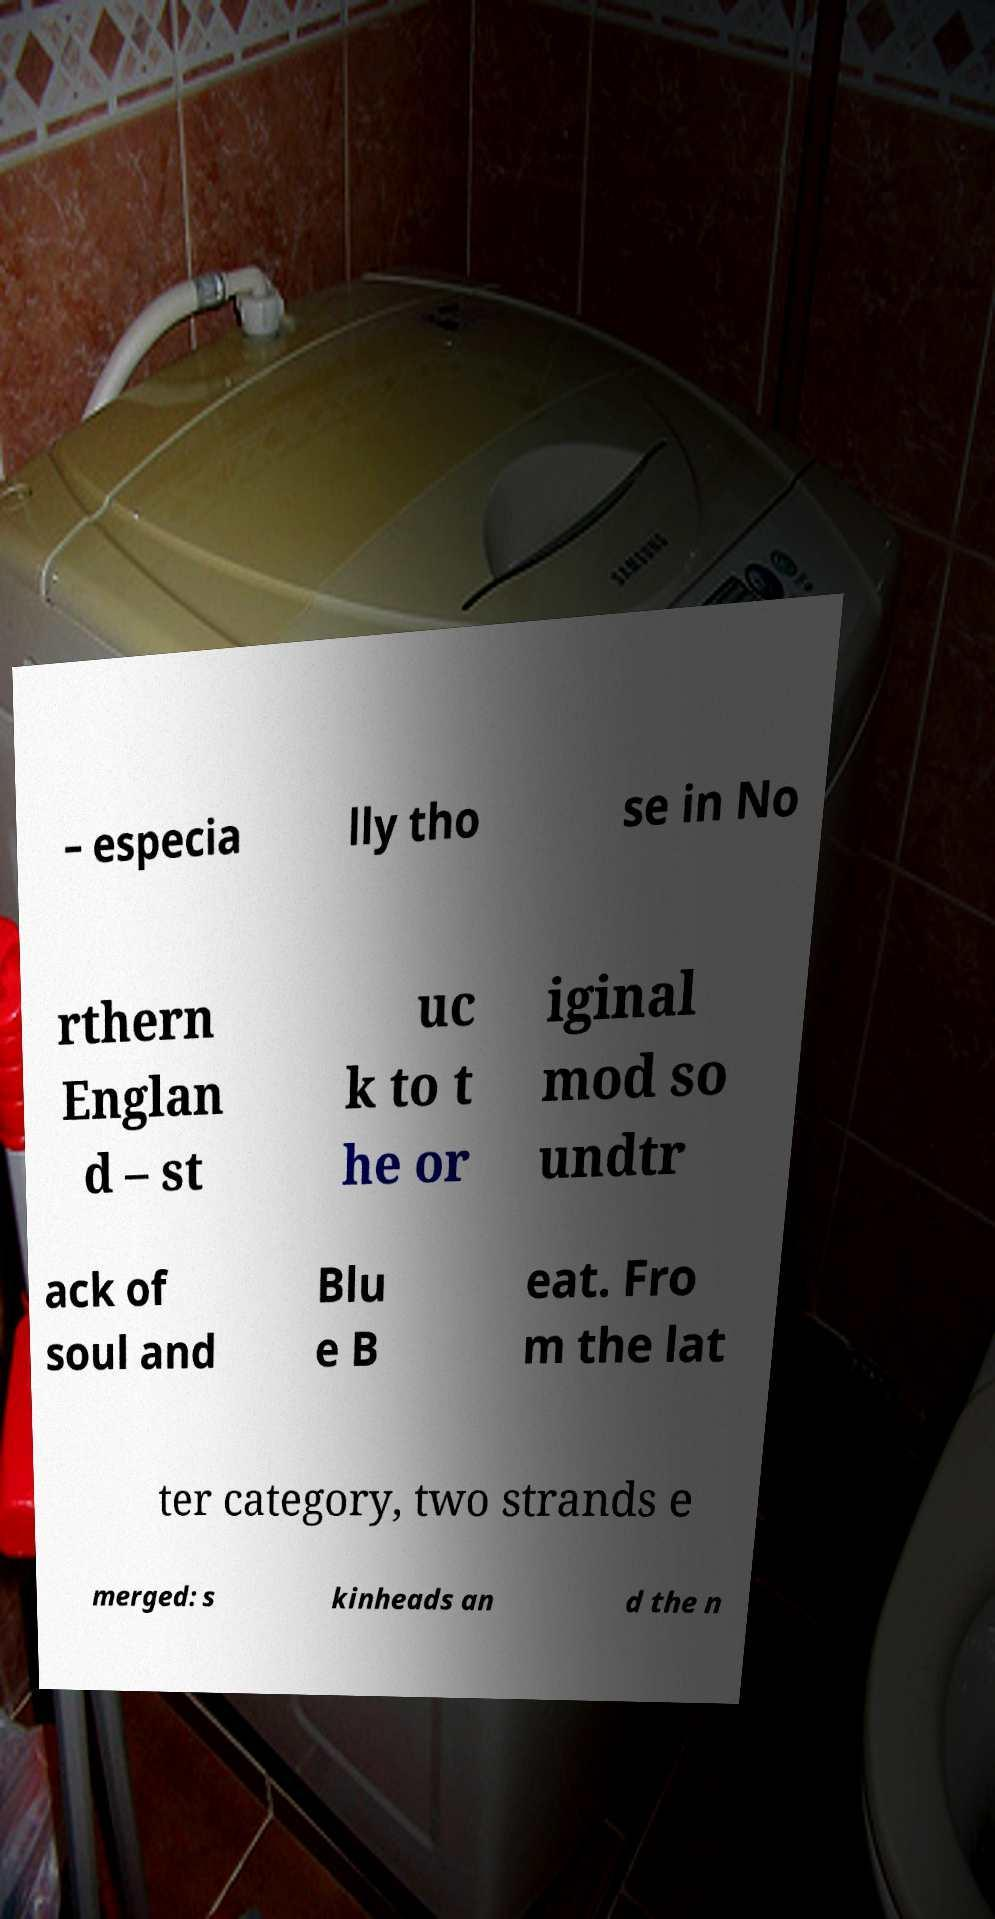Can you accurately transcribe the text from the provided image for me? – especia lly tho se in No rthern Englan d – st uc k to t he or iginal mod so undtr ack of soul and Blu e B eat. Fro m the lat ter category, two strands e merged: s kinheads an d the n 